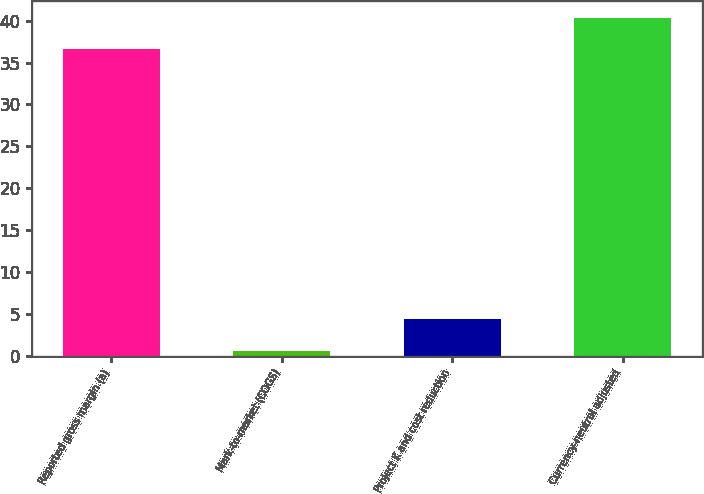Convert chart to OTSL. <chart><loc_0><loc_0><loc_500><loc_500><bar_chart><fcel>Reported gross margin (a)<fcel>Mark-to-market (COGS)<fcel>Project K and cost reduction<fcel>Currency-neutral adjusted<nl><fcel>36.6<fcel>0.6<fcel>4.34<fcel>40.34<nl></chart> 